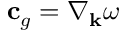Convert formula to latex. <formula><loc_0><loc_0><loc_500><loc_500>c _ { g } = \nabla _ { k } \omega</formula> 